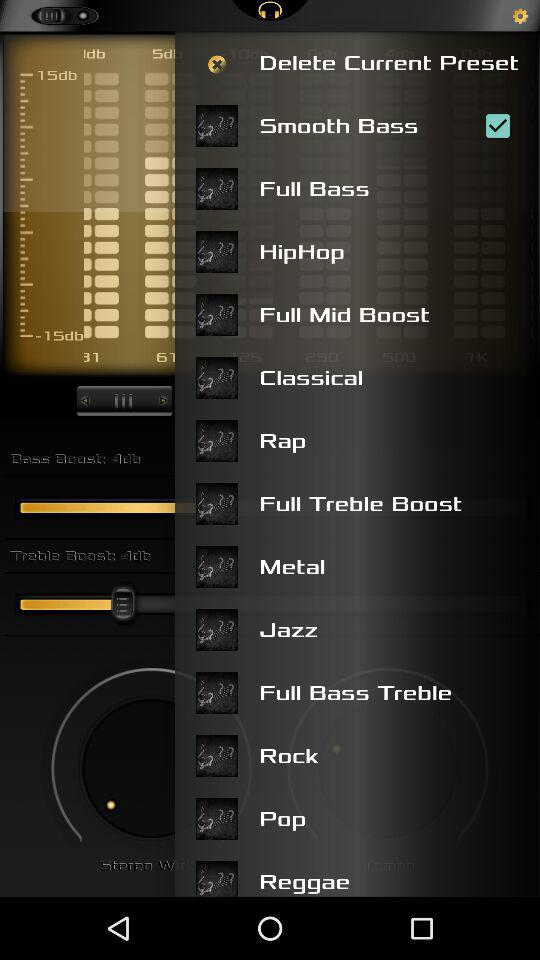What is the selected checkbox? The selected checkbox is "Smooth Bass". 